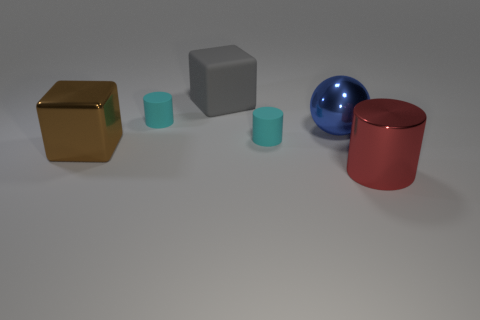Can you describe the lighting and mood of this scene? The scene is softly lit with what appears to be a diffuse light source, casting gentle shadows and giving the scene a calm, neutral feel. There is no harsh lighting or dramatic shadows, which contributes to the image's tranquil and non-distracting atmosphere. 